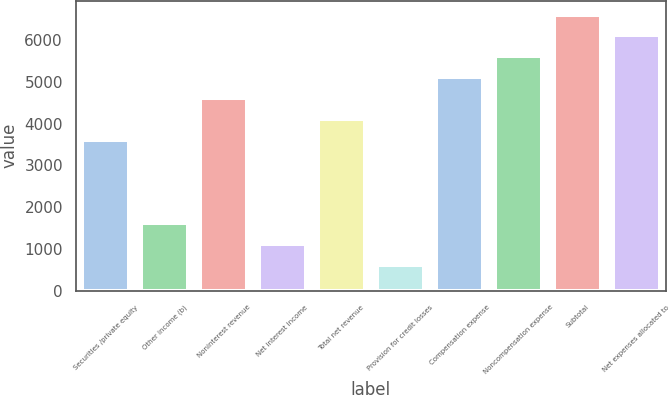Convert chart. <chart><loc_0><loc_0><loc_500><loc_500><bar_chart><fcel>Securities /private equity<fcel>Other income (b)<fcel>Noninterest revenue<fcel>Net interest income<fcel>Total net revenue<fcel>Provision for credit losses<fcel>Compensation expense<fcel>Noncompensation expense<fcel>Subtotal<fcel>Net expenses allocated to<nl><fcel>3612.3<fcel>1616.7<fcel>4610.1<fcel>1117.8<fcel>4111.2<fcel>618.9<fcel>5109<fcel>5607.9<fcel>6605.7<fcel>6106.8<nl></chart> 